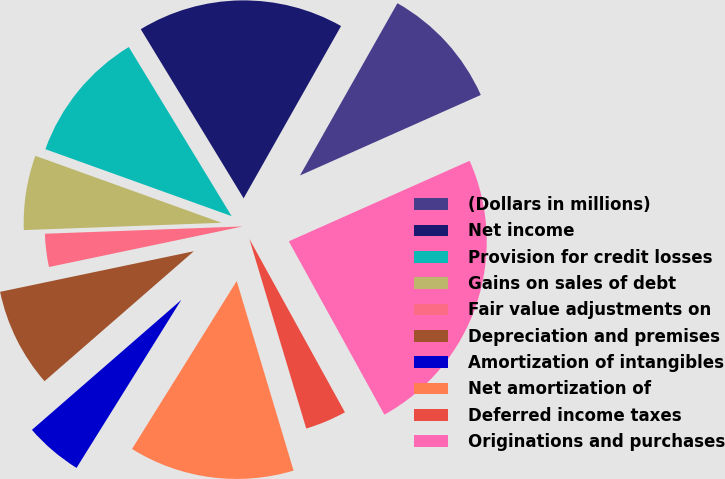Convert chart. <chart><loc_0><loc_0><loc_500><loc_500><pie_chart><fcel>(Dollars in millions)<fcel>Net income<fcel>Provision for credit losses<fcel>Gains on sales of debt<fcel>Fair value adjustments on<fcel>Depreciation and premises<fcel>Amortization of intangibles<fcel>Net amortization of<fcel>Deferred income taxes<fcel>Originations and purchases<nl><fcel>10.14%<fcel>16.89%<fcel>10.81%<fcel>6.08%<fcel>2.7%<fcel>8.11%<fcel>4.73%<fcel>13.51%<fcel>3.38%<fcel>23.65%<nl></chart> 